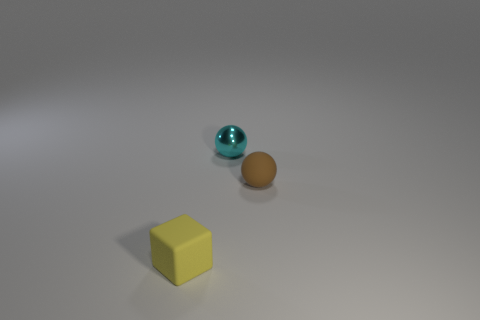Add 2 tiny rubber balls. How many objects exist? 5 Subtract all brown spheres. How many spheres are left? 1 Subtract all cyan cubes. How many brown balls are left? 1 Add 1 big blue rubber objects. How many big blue rubber objects exist? 1 Subtract 0 red blocks. How many objects are left? 3 Subtract all balls. How many objects are left? 1 Subtract 1 spheres. How many spheres are left? 1 Subtract all green blocks. Subtract all green spheres. How many blocks are left? 1 Subtract all tiny metal spheres. Subtract all small cubes. How many objects are left? 1 Add 1 brown rubber objects. How many brown rubber objects are left? 2 